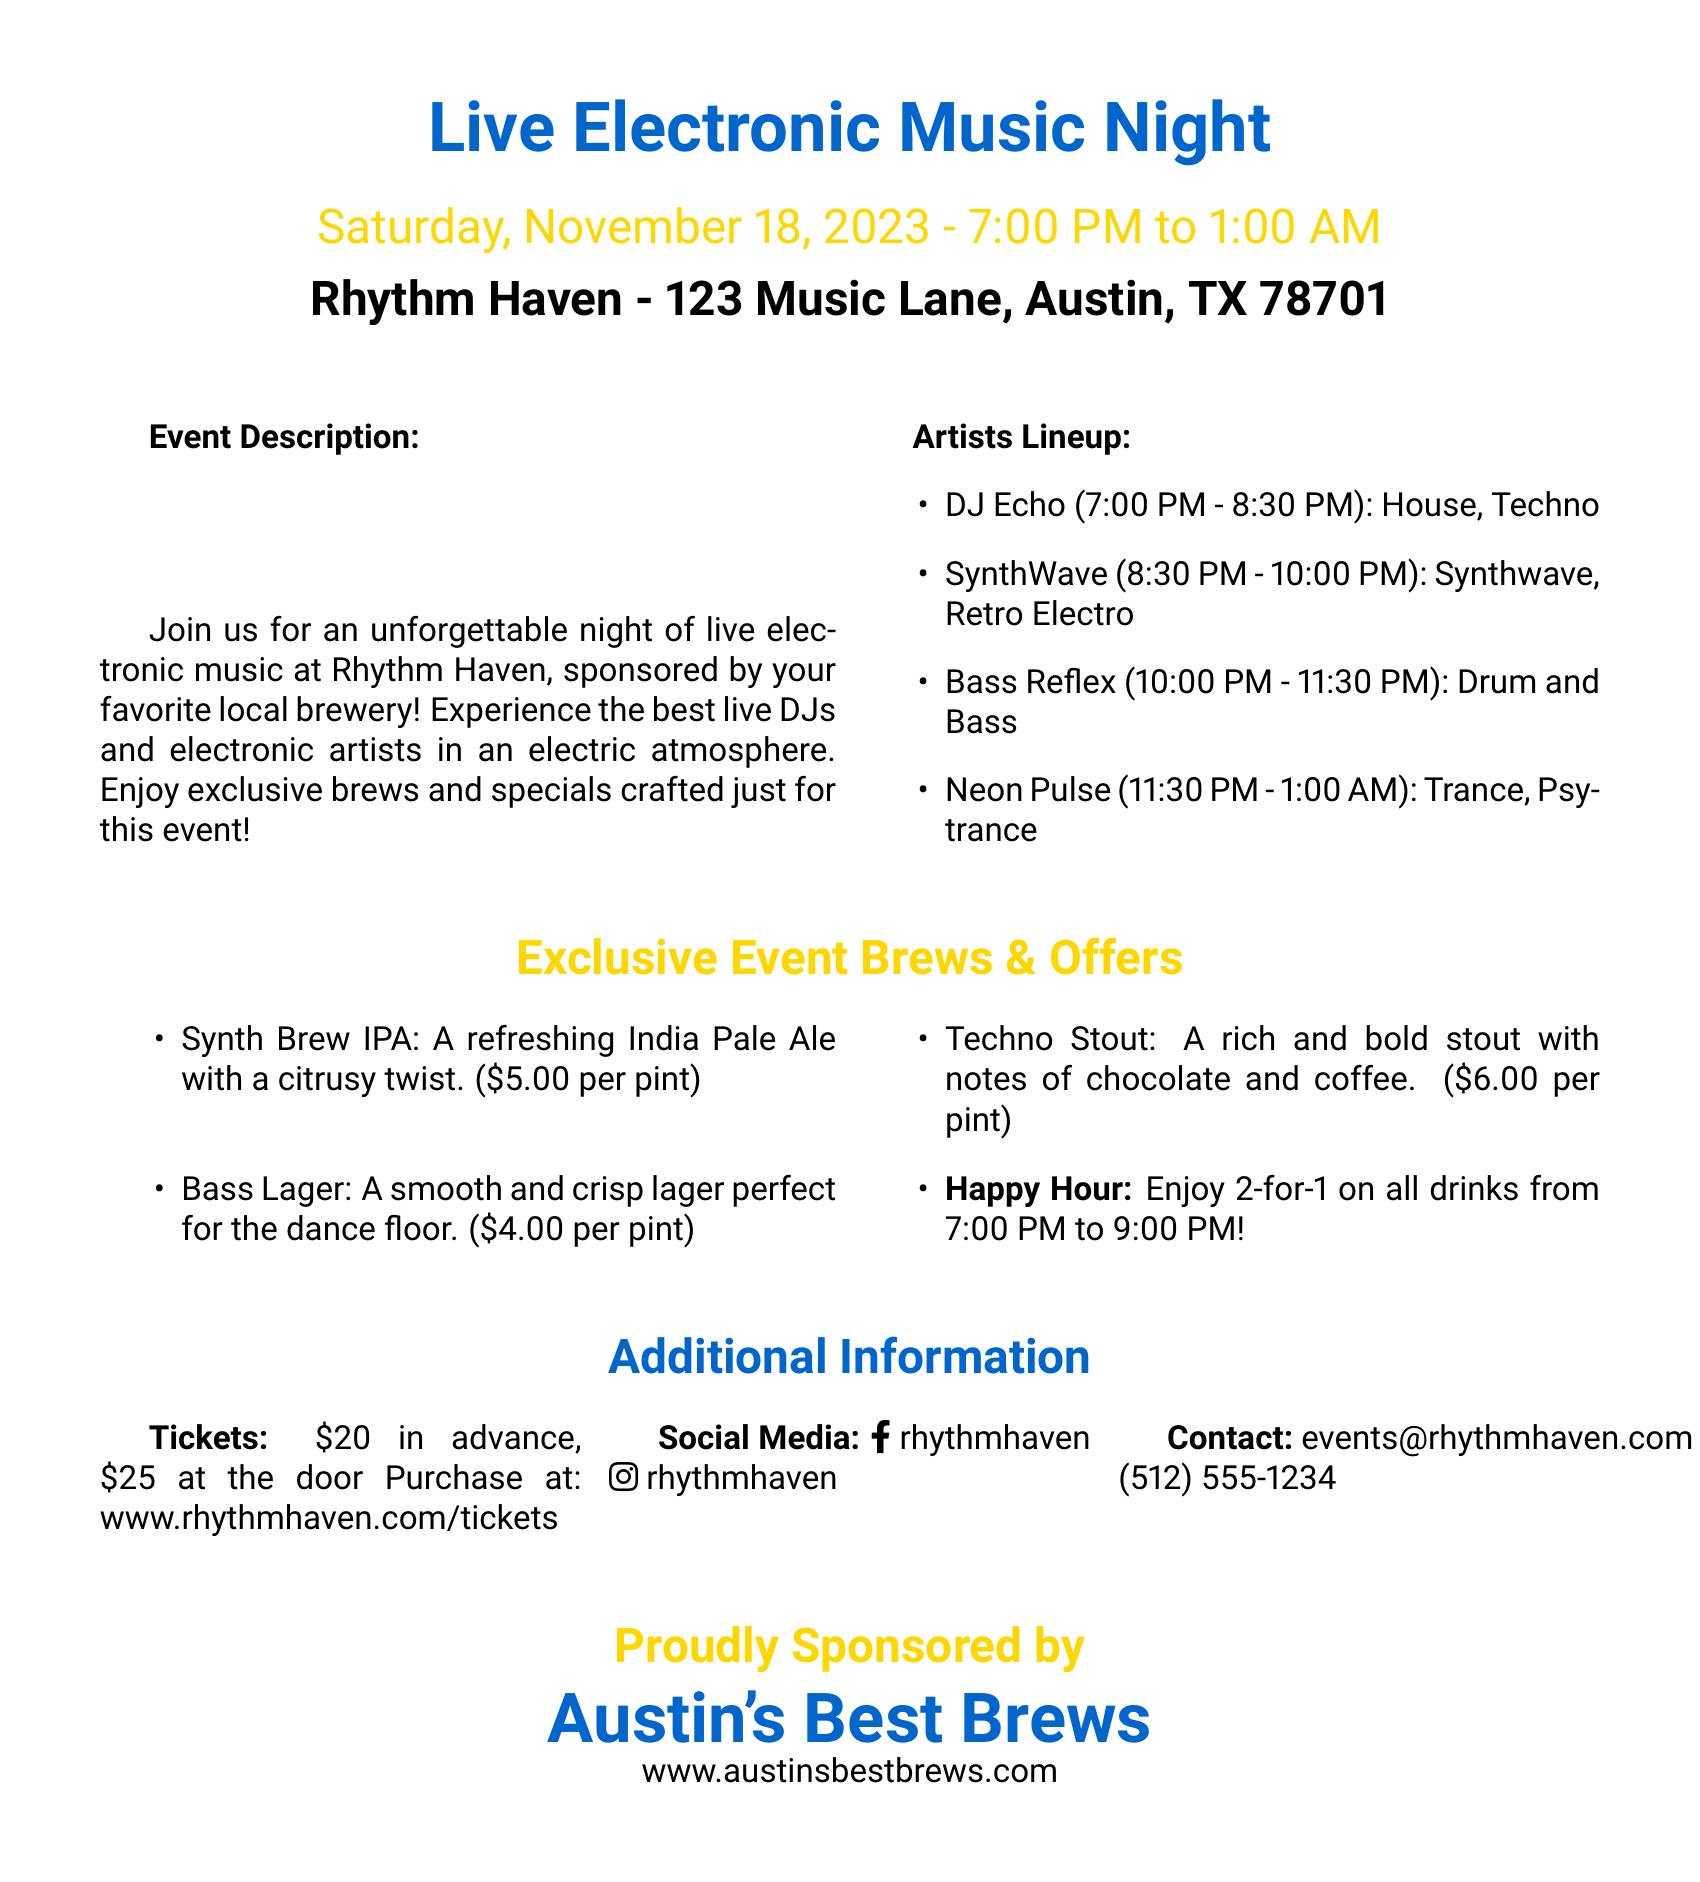What is the date of the event? The date of the event is clearly stated in the document as Saturday, November 18, 2023.
Answer: Saturday, November 18, 2023 What time does the event start? The starting time for the event is mentioned as 7:00 PM.
Answer: 7:00 PM How much is the ticket at the door? The price for tickets at the door is listed as $25.
Answer: $25 What type of beer is Synth Brew? Synth Brew is described as a refreshing India Pale Ale.
Answer: India Pale Ale What promotional offer is available from 7:00 PM to 9:00 PM? The document states a 2-for-1 drink offer during that timeframe.
Answer: 2-for-1 on all drinks Who is the artist performing from 10:00 PM to 11:30 PM? The document lists Bass Reflex as the artist for that time slot.
Answer: Bass Reflex What is the name of the venue hosting the event? The venue name is provided as Rhythm Haven.
Answer: Rhythm Haven What is the contact email for the event? The contact email for the event is mentioned as events@rhythmhaven.com.
Answer: events@rhythmhaven.com How many artists are listed in the lineup? The document includes a total of four artists in the lineup.
Answer: Four 